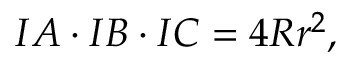Convert formula to latex. <formula><loc_0><loc_0><loc_500><loc_500>I A \cdot I B \cdot I C = 4 R r ^ { 2 } ,</formula> 